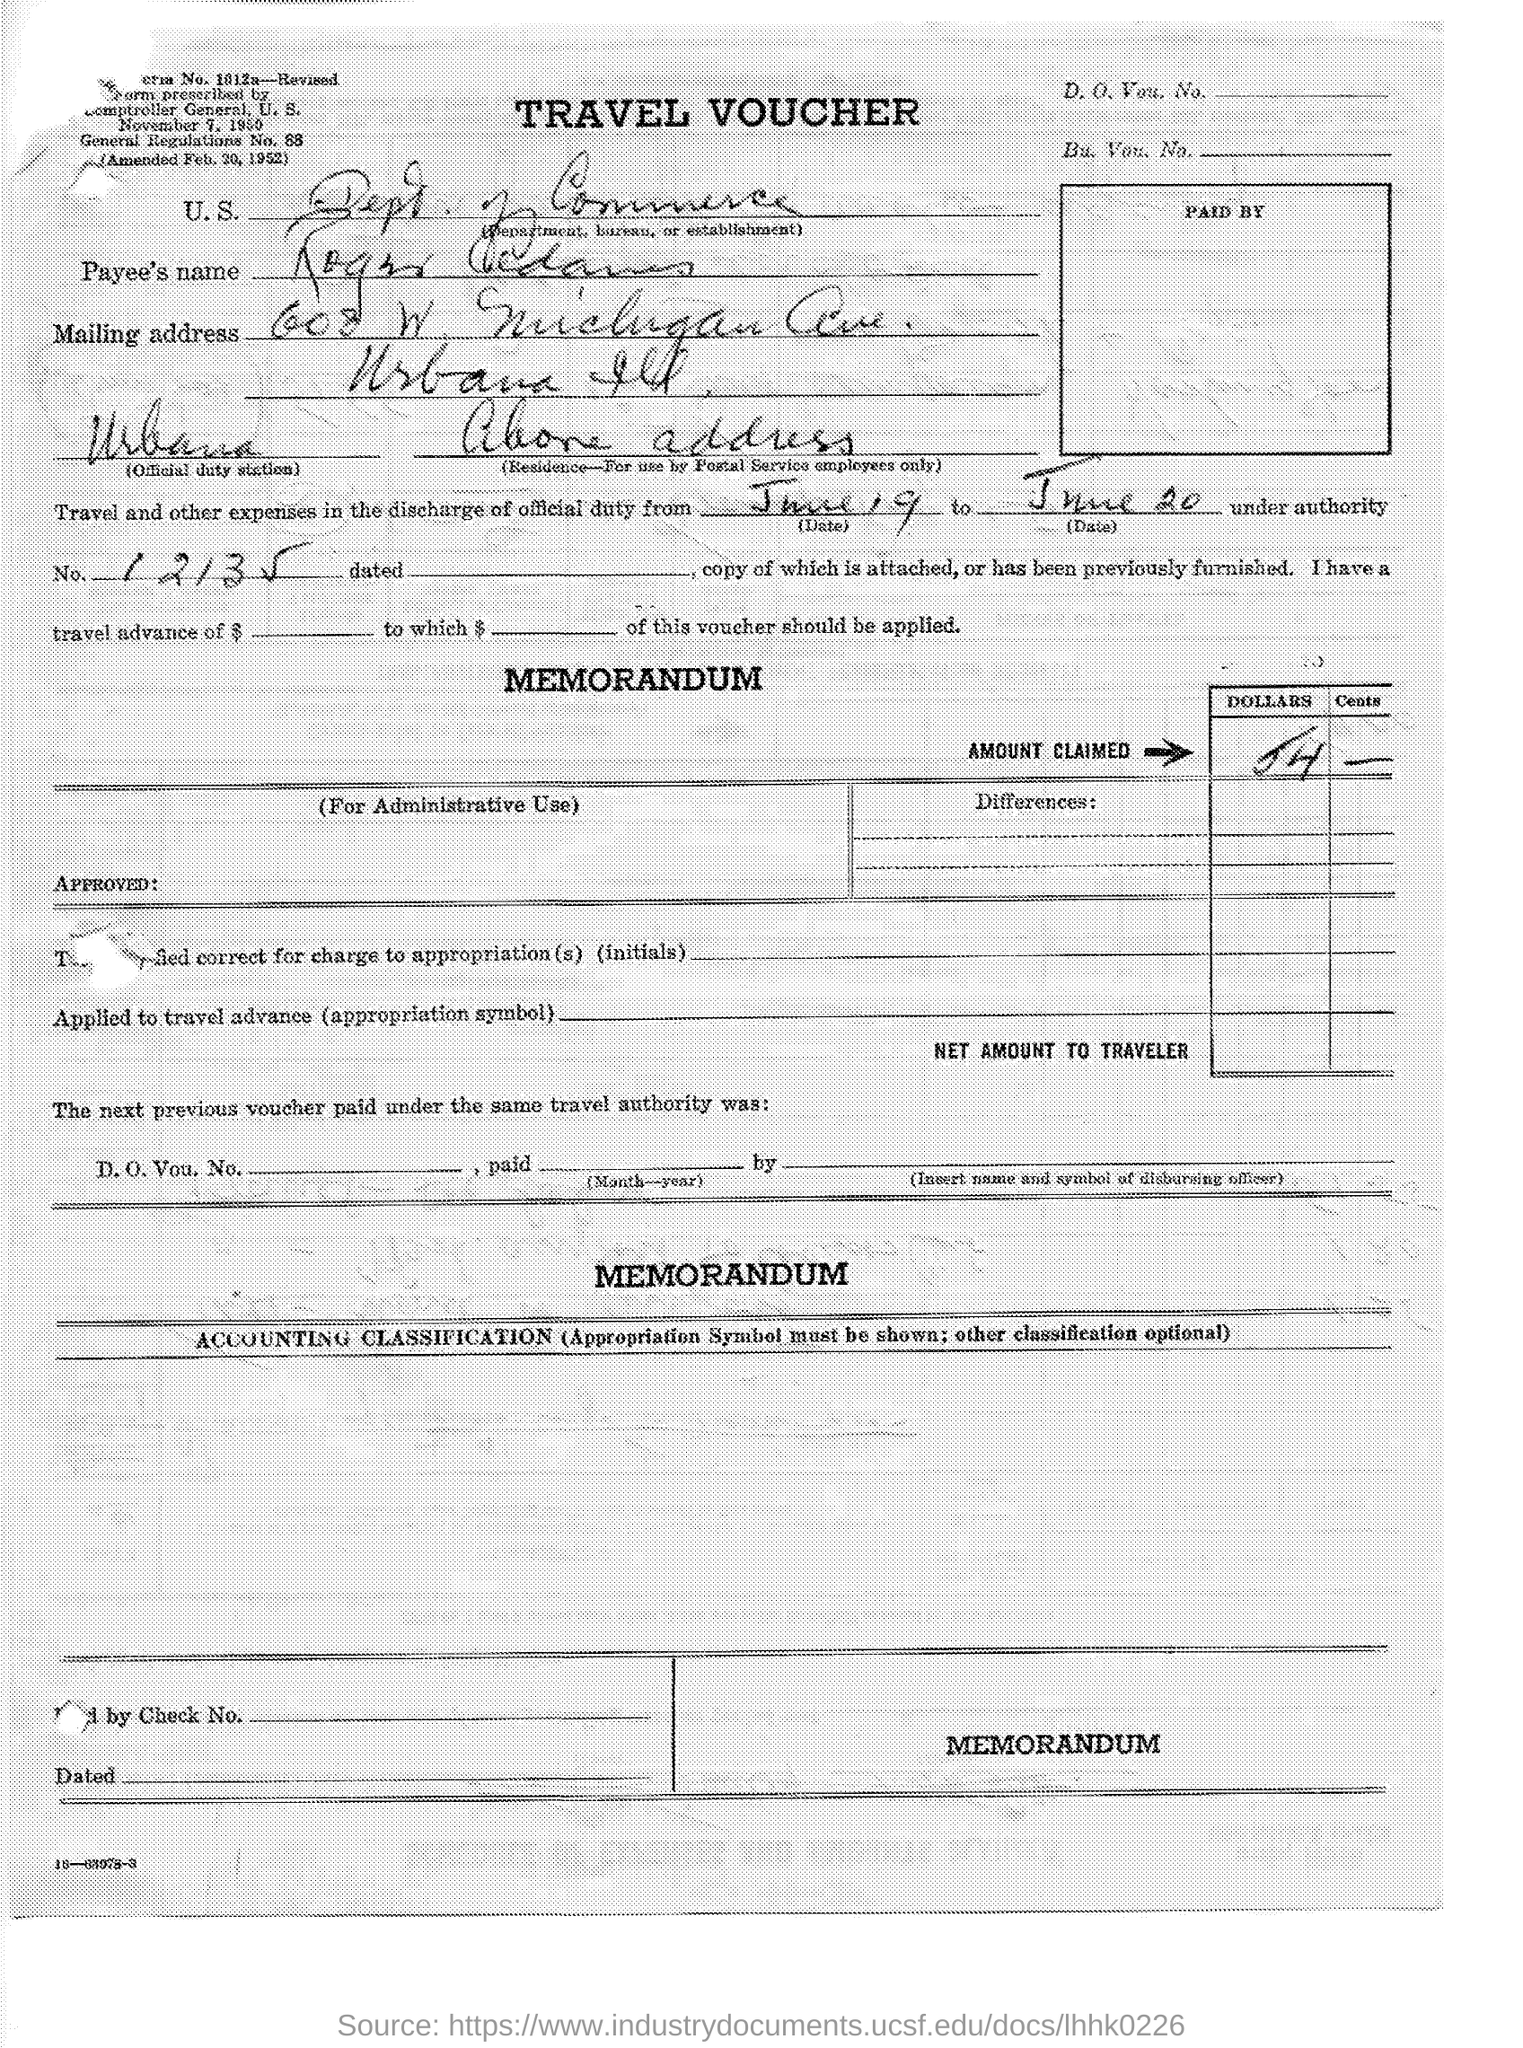Outline some significant characteristics in this image. The type of documentation in question is a travel voucher. 